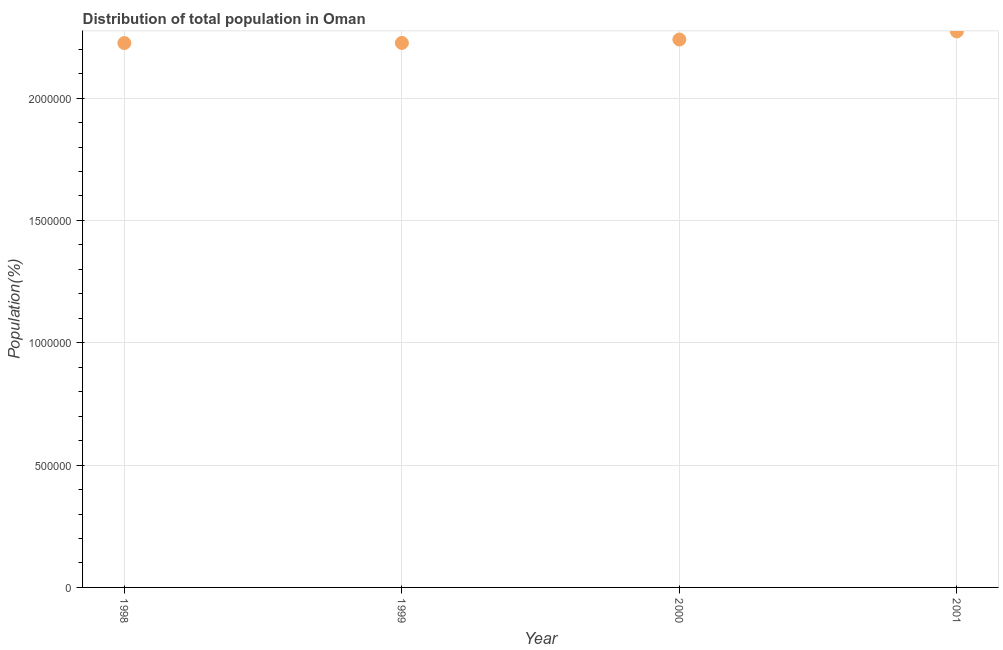What is the population in 2000?
Provide a short and direct response. 2.24e+06. Across all years, what is the maximum population?
Keep it short and to the point. 2.27e+06. Across all years, what is the minimum population?
Ensure brevity in your answer.  2.22e+06. What is the sum of the population?
Your answer should be compact. 8.96e+06. What is the difference between the population in 1998 and 1999?
Give a very brief answer. -559. What is the average population per year?
Offer a terse response. 2.24e+06. What is the median population?
Provide a succinct answer. 2.23e+06. In how many years, is the population greater than 500000 %?
Provide a short and direct response. 4. What is the ratio of the population in 1999 to that in 2000?
Keep it short and to the point. 0.99. Is the population in 1998 less than that in 1999?
Provide a succinct answer. Yes. What is the difference between the highest and the second highest population?
Your answer should be very brief. 3.31e+04. What is the difference between the highest and the lowest population?
Provide a short and direct response. 4.76e+04. Does the population monotonically increase over the years?
Provide a succinct answer. Yes. How many years are there in the graph?
Your answer should be very brief. 4. Does the graph contain grids?
Offer a terse response. Yes. What is the title of the graph?
Provide a short and direct response. Distribution of total population in Oman . What is the label or title of the X-axis?
Give a very brief answer. Year. What is the label or title of the Y-axis?
Your answer should be compact. Population(%). What is the Population(%) in 1998?
Offer a terse response. 2.22e+06. What is the Population(%) in 1999?
Ensure brevity in your answer.  2.23e+06. What is the Population(%) in 2000?
Give a very brief answer. 2.24e+06. What is the Population(%) in 2001?
Provide a short and direct response. 2.27e+06. What is the difference between the Population(%) in 1998 and 1999?
Your answer should be compact. -559. What is the difference between the Population(%) in 1998 and 2000?
Give a very brief answer. -1.45e+04. What is the difference between the Population(%) in 1998 and 2001?
Keep it short and to the point. -4.76e+04. What is the difference between the Population(%) in 1999 and 2000?
Provide a short and direct response. -1.39e+04. What is the difference between the Population(%) in 1999 and 2001?
Give a very brief answer. -4.71e+04. What is the difference between the Population(%) in 2000 and 2001?
Give a very brief answer. -3.31e+04. What is the ratio of the Population(%) in 1998 to that in 1999?
Provide a short and direct response. 1. What is the ratio of the Population(%) in 1998 to that in 2000?
Keep it short and to the point. 0.99. What is the ratio of the Population(%) in 1998 to that in 2001?
Offer a very short reply. 0.98. What is the ratio of the Population(%) in 1999 to that in 2000?
Your answer should be very brief. 0.99. What is the ratio of the Population(%) in 1999 to that in 2001?
Offer a terse response. 0.98. What is the ratio of the Population(%) in 2000 to that in 2001?
Keep it short and to the point. 0.98. 